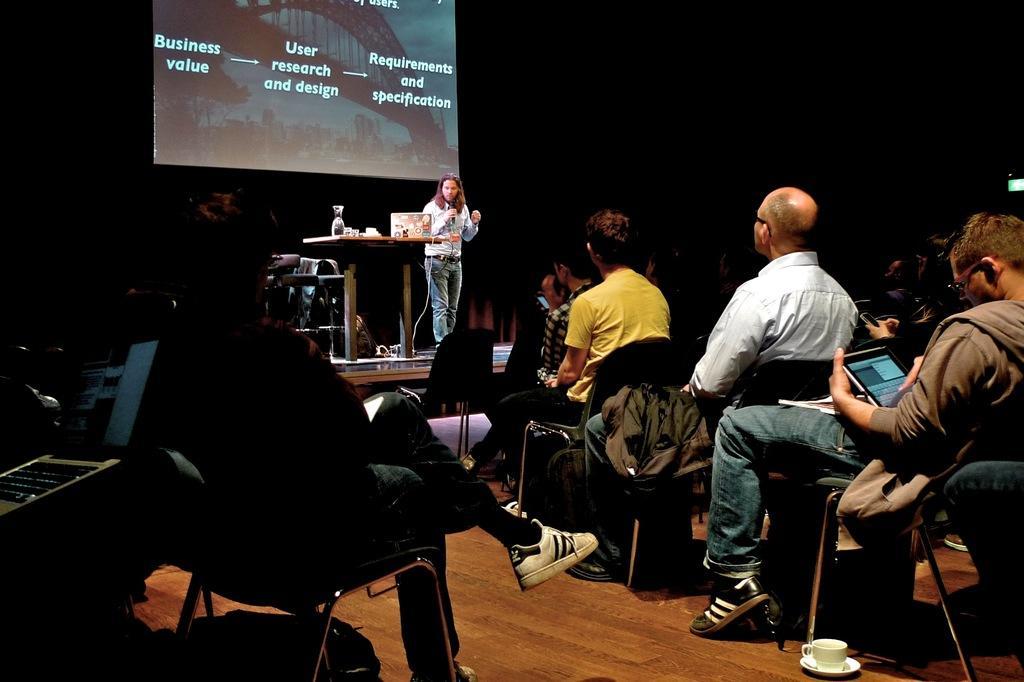Please provide a concise description of this image. This image is taken indoors. In this image the background is dark. There is a board with a text on and an image on it. At the bottom of the image there is a floor. In the middle of the image a man is standing on the dais and there is a table with a few things on it. On the left side of the image a few are sitting on the chairs and a person is holding a laptop. On the right side of the image many people are sitting on the chairs and a man is holding a laptop in his hands. There is a cup and a saucer on the floor. 